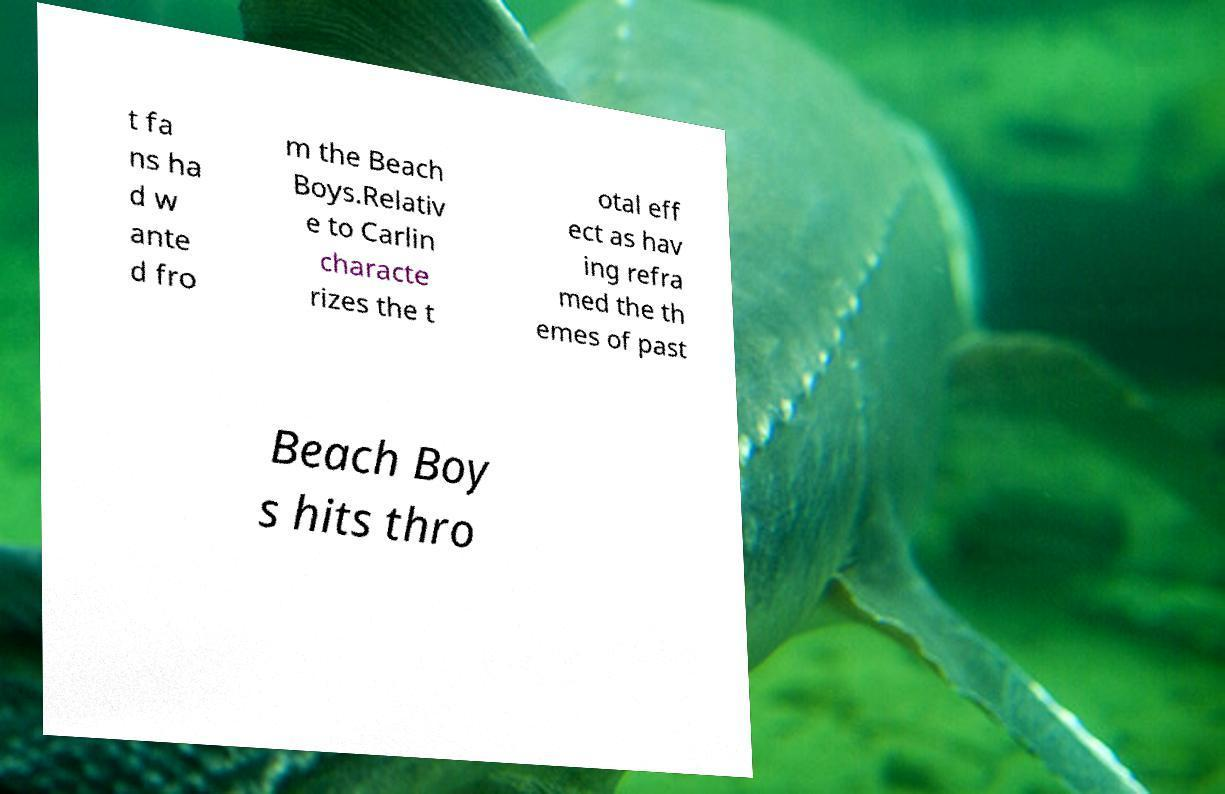Could you extract and type out the text from this image? t fa ns ha d w ante d fro m the Beach Boys.Relativ e to Carlin characte rizes the t otal eff ect as hav ing refra med the th emes of past Beach Boy s hits thro 